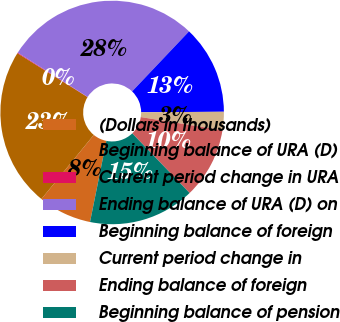Convert chart to OTSL. <chart><loc_0><loc_0><loc_500><loc_500><pie_chart><fcel>(Dollars in thousands)<fcel>Beginning balance of URA (D)<fcel>Current period change in URA<fcel>Ending balance of URA (D) on<fcel>Beginning balance of foreign<fcel>Current period change in<fcel>Ending balance of foreign<fcel>Beginning balance of pension<nl><fcel>7.73%<fcel>22.99%<fcel>0.1%<fcel>28.08%<fcel>12.82%<fcel>2.64%<fcel>10.27%<fcel>15.36%<nl></chart> 